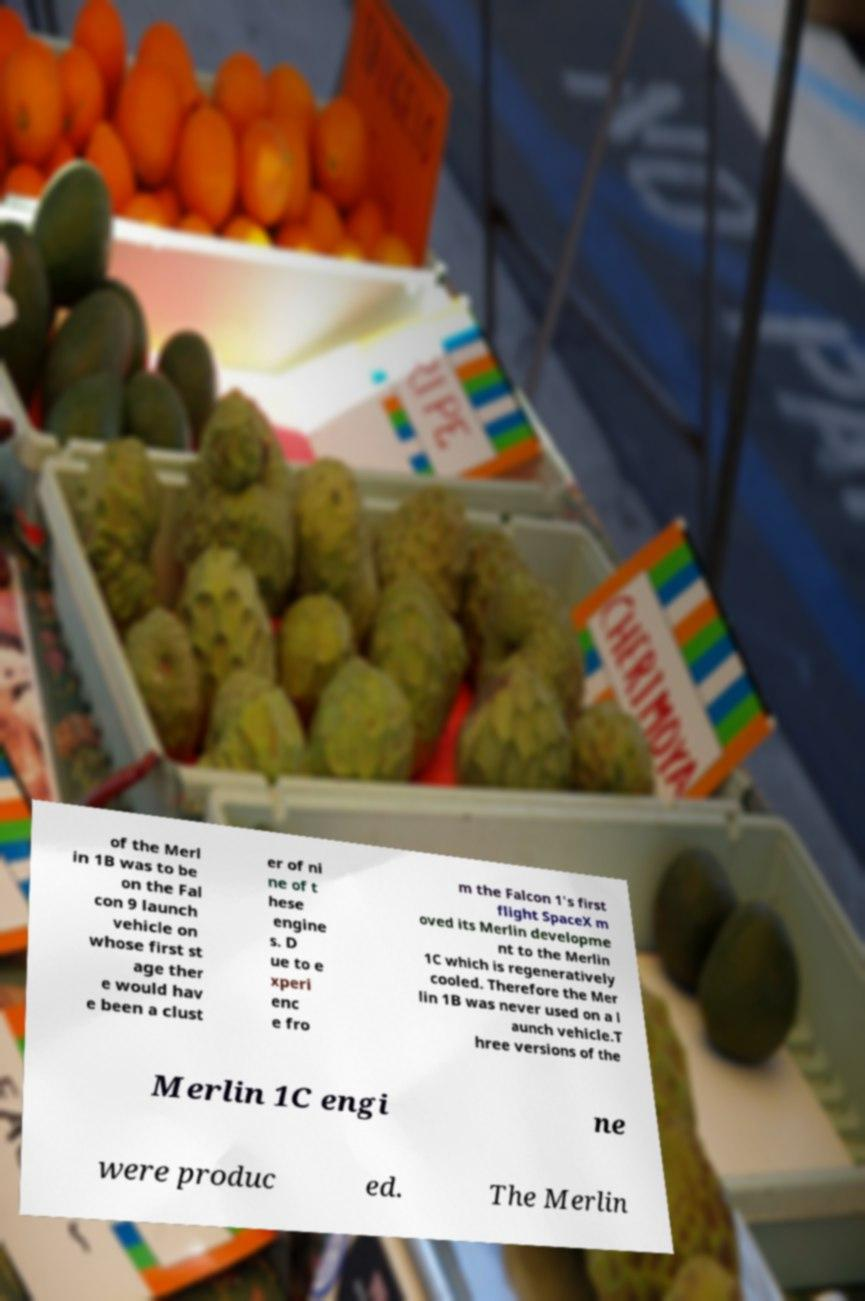I need the written content from this picture converted into text. Can you do that? of the Merl in 1B was to be on the Fal con 9 launch vehicle on whose first st age ther e would hav e been a clust er of ni ne of t hese engine s. D ue to e xperi enc e fro m the Falcon 1's first flight SpaceX m oved its Merlin developme nt to the Merlin 1C which is regeneratively cooled. Therefore the Mer lin 1B was never used on a l aunch vehicle.T hree versions of the Merlin 1C engi ne were produc ed. The Merlin 